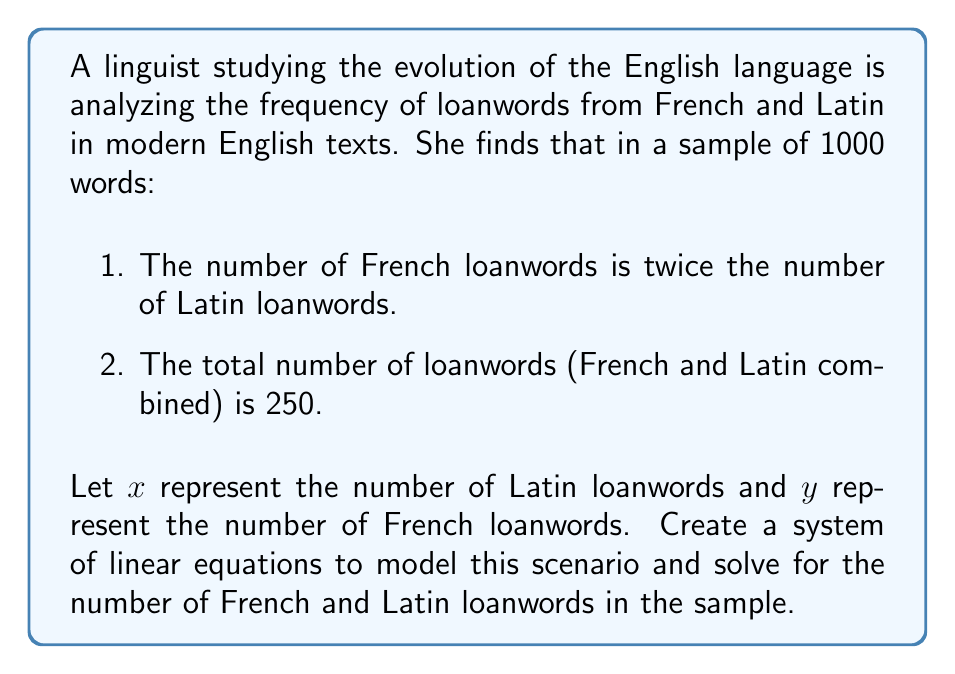Provide a solution to this math problem. To solve this problem, we'll follow these steps:

1. Set up the system of linear equations based on the given information.
2. Solve the system using substitution method.

Step 1: Setting up the system of linear equations

From the given information:
1. The number of French loanwords is twice the number of Latin loanwords:
   $$y = 2x$$

2. The total number of loanwords is 250:
   $$x + y = 250$$

Our system of linear equations is:
$$\begin{cases}
y = 2x \\
x + y = 250
\end{cases}$$

Step 2: Solving the system using substitution method

Substitute the first equation into the second:
$$x + 2x = 250$$
$$3x = 250$$

Solve for $x$:
$$x = \frac{250}{3} \approx 83.33$$

Since we're dealing with whole words, we round down to the nearest integer:
$$x = 83$$

Now, substitute this value back into the first equation to find $y$:
$$y = 2x = 2(83) = 166$$

Therefore, there are 83 Latin loanwords and 166 French loanwords in the sample.
Answer: Latin loanwords: 83
French loanwords: 166 